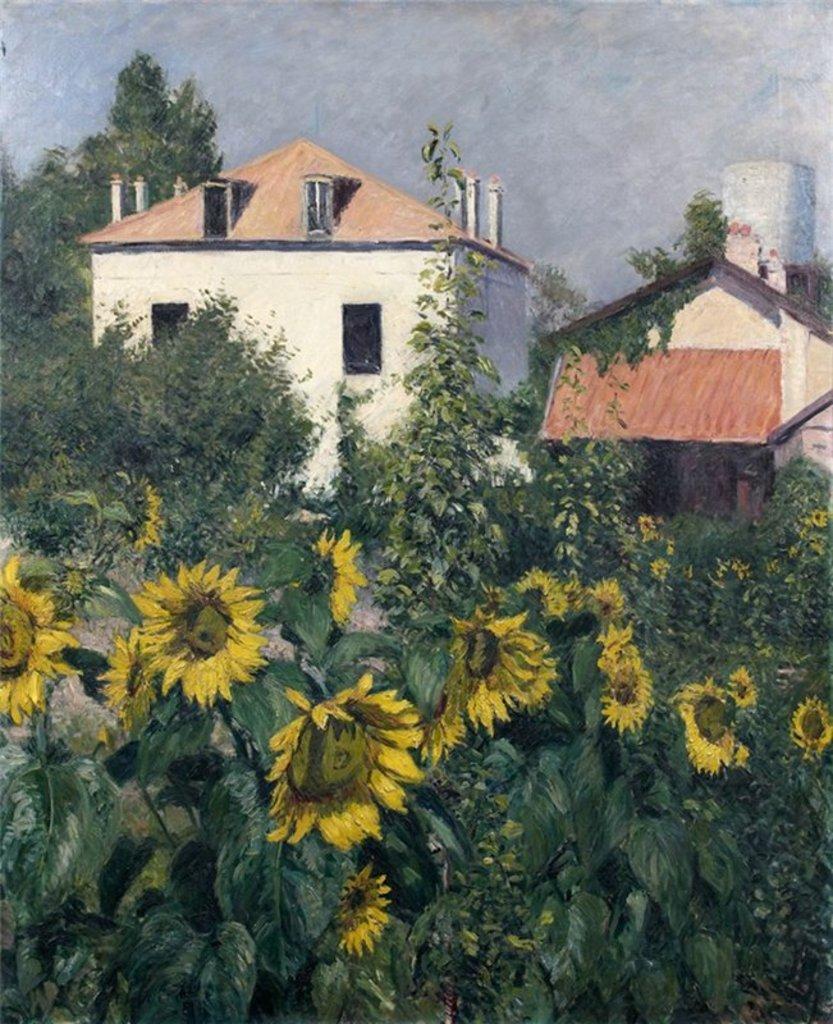What types of plants are in the foreground of the image? There are flowers and plants in the foreground of the image. What can be seen in the background of the image? There are houses, trees, and the sky visible in the background of the image. What type of instrument is the actor playing in the image? There is no actor or instrument present in the image. 